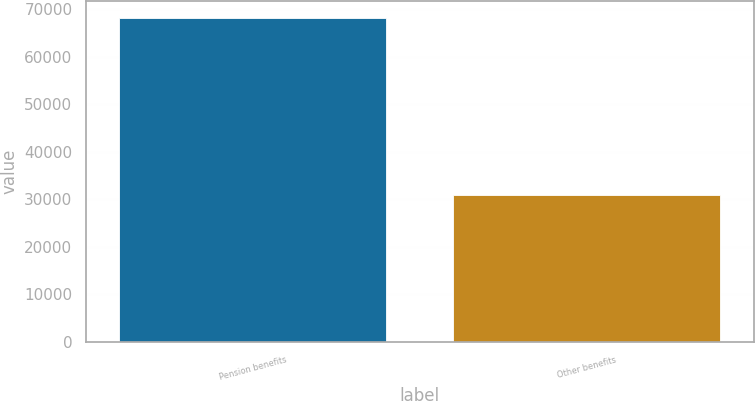<chart> <loc_0><loc_0><loc_500><loc_500><bar_chart><fcel>Pension benefits<fcel>Other benefits<nl><fcel>68221<fcel>31002<nl></chart> 